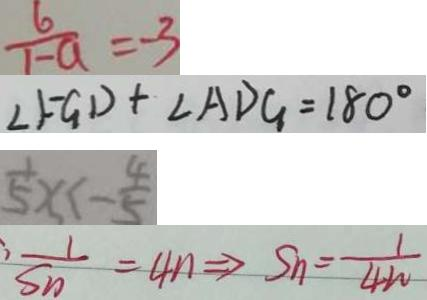<formula> <loc_0><loc_0><loc_500><loc_500>\frac { 6 } { 1 - a } = - 3 
 \angle F G D + \angle A D G = 1 8 0 ^ { \circ } 
 \frac { 1 } { 5 } x < - \frac { 4 } { 5 } 
 \cdot \frac { 1 } { S _ { n } } = 4 n \Rightarrow S _ { n } = \frac { 1 } { 4 w }</formula> 